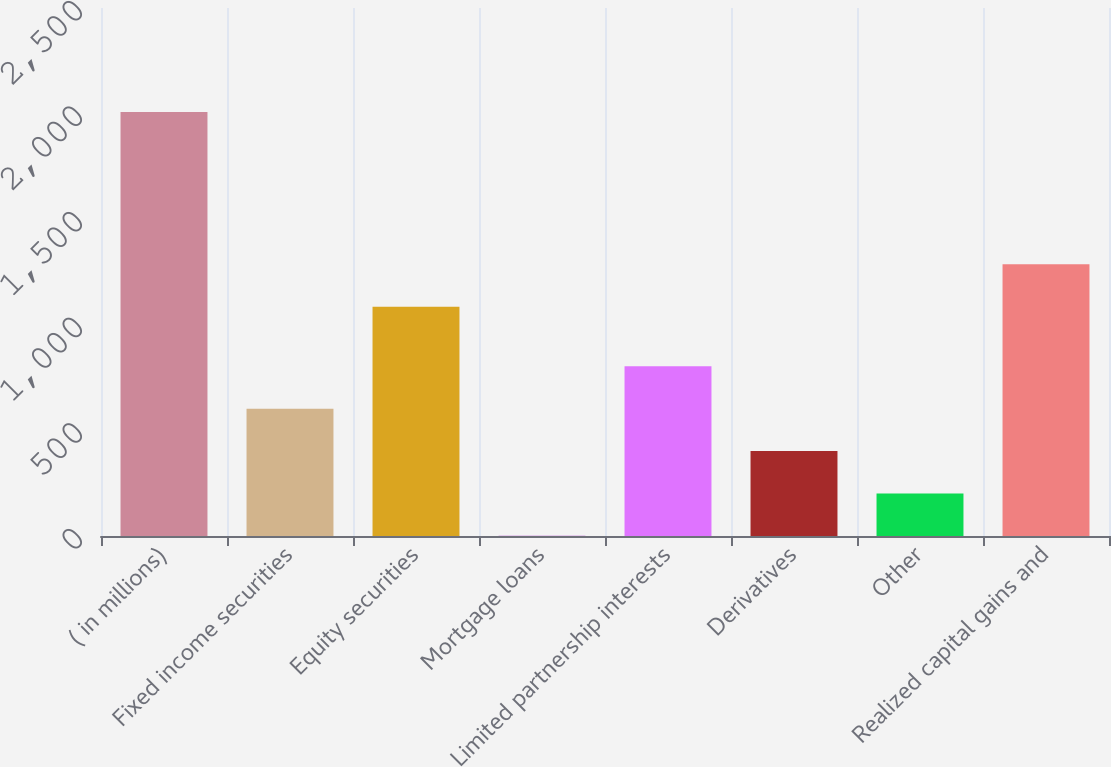<chart> <loc_0><loc_0><loc_500><loc_500><bar_chart><fcel>( in millions)<fcel>Fixed income securities<fcel>Equity securities<fcel>Mortgage loans<fcel>Limited partnership interests<fcel>Derivatives<fcel>Other<fcel>Realized capital gains and<nl><fcel>2007<fcel>602.8<fcel>1086<fcel>1<fcel>803.4<fcel>402.2<fcel>201.6<fcel>1286.6<nl></chart> 